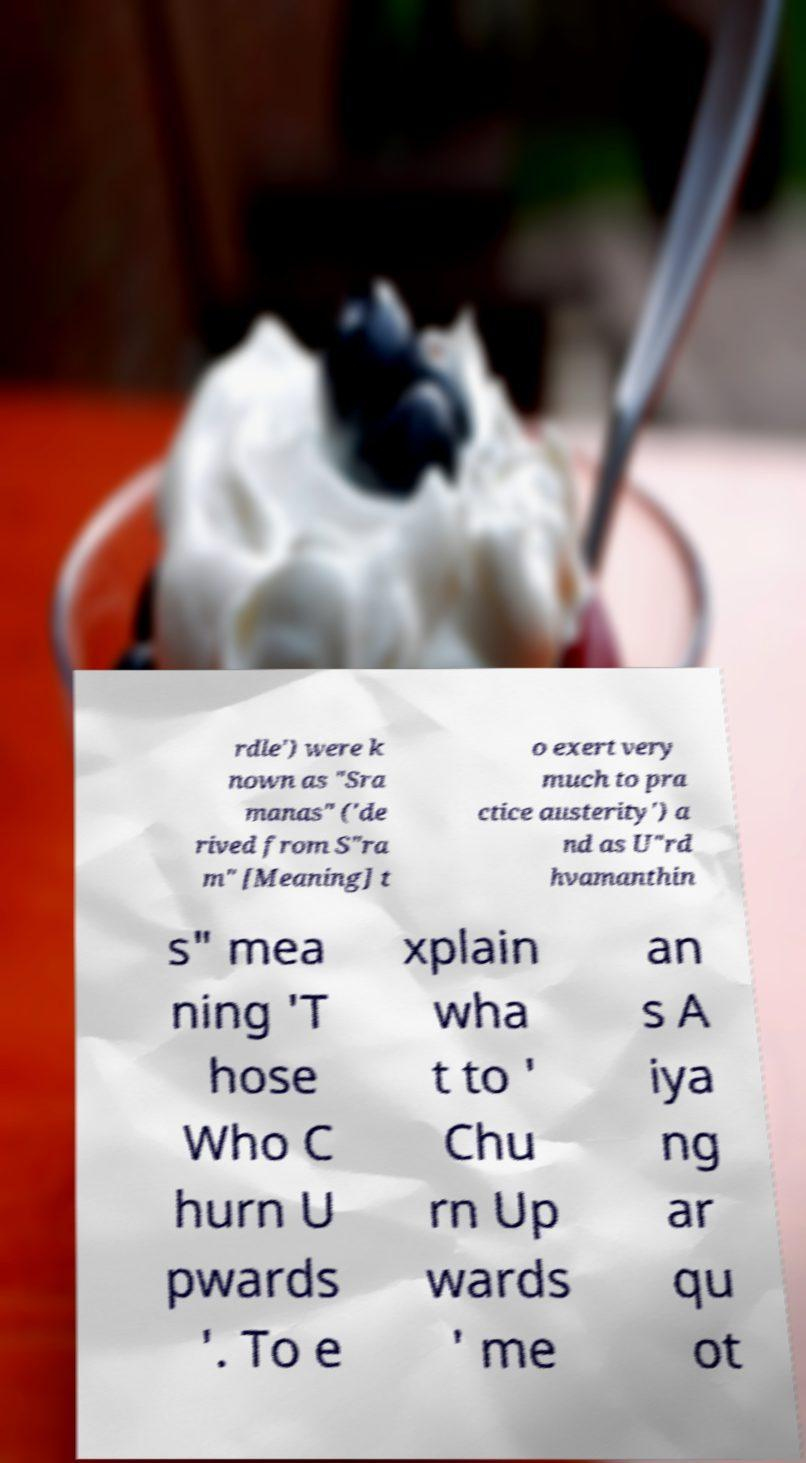What messages or text are displayed in this image? I need them in a readable, typed format. rdle') were k nown as "Sra manas" ('de rived from S"ra m" [Meaning] t o exert very much to pra ctice austerity') a nd as U"rd hvamanthin s" mea ning 'T hose Who C hurn U pwards '. To e xplain wha t to ' Chu rn Up wards ' me an s A iya ng ar qu ot 